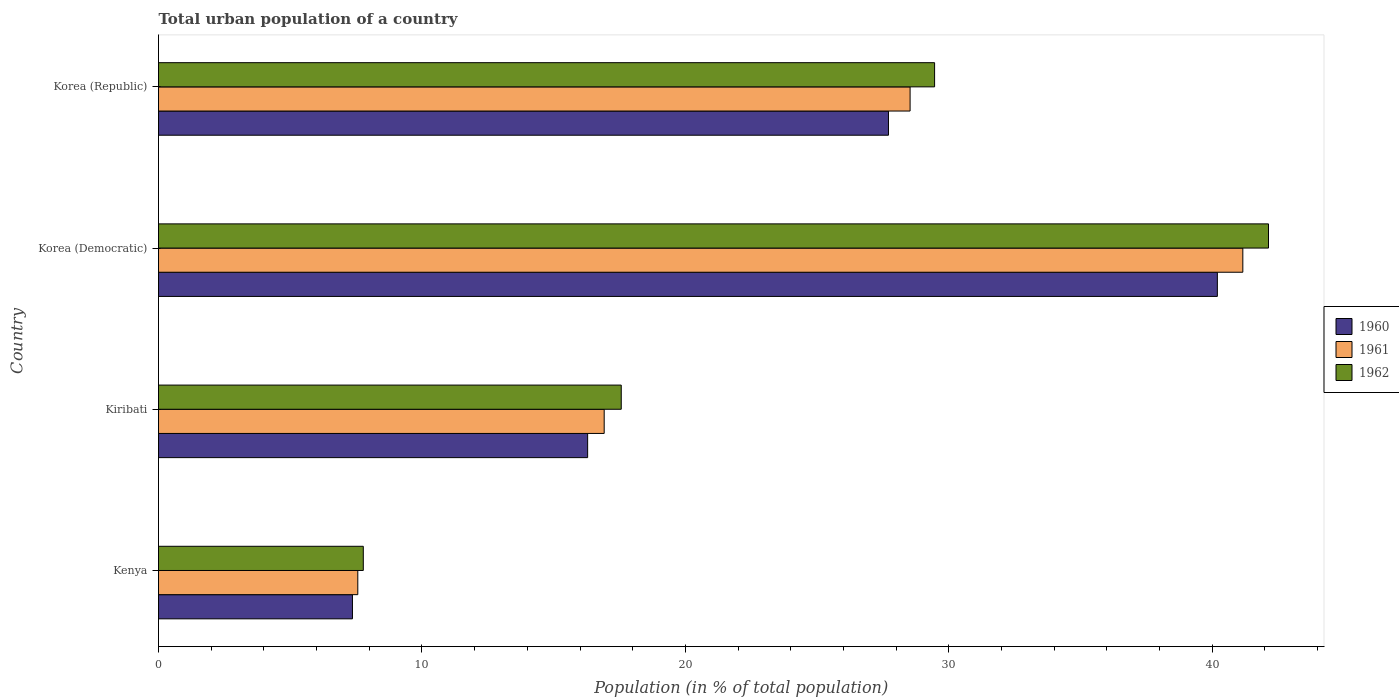How many groups of bars are there?
Your answer should be compact. 4. Are the number of bars per tick equal to the number of legend labels?
Ensure brevity in your answer.  Yes. How many bars are there on the 2nd tick from the top?
Your response must be concise. 3. How many bars are there on the 3rd tick from the bottom?
Ensure brevity in your answer.  3. What is the urban population in 1962 in Korea (Republic)?
Your answer should be compact. 29.46. Across all countries, what is the maximum urban population in 1960?
Give a very brief answer. 40.2. Across all countries, what is the minimum urban population in 1960?
Offer a terse response. 7.36. In which country was the urban population in 1960 maximum?
Your answer should be very brief. Korea (Democratic). In which country was the urban population in 1962 minimum?
Provide a short and direct response. Kenya. What is the total urban population in 1960 in the graph?
Your answer should be very brief. 91.56. What is the difference between the urban population in 1960 in Kenya and that in Korea (Republic)?
Make the answer very short. -20.35. What is the difference between the urban population in 1960 in Kiribati and the urban population in 1961 in Kenya?
Provide a short and direct response. 8.72. What is the average urban population in 1961 per country?
Offer a terse response. 23.54. What is the difference between the urban population in 1962 and urban population in 1960 in Korea (Democratic)?
Your answer should be compact. 1.94. What is the ratio of the urban population in 1960 in Kenya to that in Korea (Republic)?
Keep it short and to the point. 0.27. Is the urban population in 1962 in Kiribati less than that in Korea (Republic)?
Keep it short and to the point. Yes. Is the difference between the urban population in 1962 in Kiribati and Korea (Democratic) greater than the difference between the urban population in 1960 in Kiribati and Korea (Democratic)?
Offer a terse response. No. What is the difference between the highest and the second highest urban population in 1962?
Give a very brief answer. 12.68. What is the difference between the highest and the lowest urban population in 1962?
Provide a succinct answer. 34.36. In how many countries, is the urban population in 1961 greater than the average urban population in 1961 taken over all countries?
Your answer should be compact. 2. Is the sum of the urban population in 1960 in Kiribati and Korea (Democratic) greater than the maximum urban population in 1961 across all countries?
Offer a very short reply. Yes. What does the 2nd bar from the bottom in Korea (Republic) represents?
Your response must be concise. 1961. Is it the case that in every country, the sum of the urban population in 1962 and urban population in 1961 is greater than the urban population in 1960?
Provide a short and direct response. Yes. Are all the bars in the graph horizontal?
Your answer should be very brief. Yes. What is the difference between two consecutive major ticks on the X-axis?
Ensure brevity in your answer.  10. Are the values on the major ticks of X-axis written in scientific E-notation?
Make the answer very short. No. Does the graph contain any zero values?
Give a very brief answer. No. Where does the legend appear in the graph?
Your response must be concise. Center right. What is the title of the graph?
Provide a short and direct response. Total urban population of a country. What is the label or title of the X-axis?
Offer a very short reply. Population (in % of total population). What is the label or title of the Y-axis?
Offer a very short reply. Country. What is the Population (in % of total population) in 1960 in Kenya?
Ensure brevity in your answer.  7.36. What is the Population (in % of total population) in 1961 in Kenya?
Your answer should be compact. 7.57. What is the Population (in % of total population) of 1962 in Kenya?
Keep it short and to the point. 7.77. What is the Population (in % of total population) in 1960 in Kiribati?
Make the answer very short. 16.29. What is the Population (in % of total population) of 1961 in Kiribati?
Give a very brief answer. 16.92. What is the Population (in % of total population) of 1962 in Kiribati?
Provide a succinct answer. 17.57. What is the Population (in % of total population) in 1960 in Korea (Democratic)?
Your answer should be very brief. 40.2. What is the Population (in % of total population) in 1961 in Korea (Democratic)?
Provide a short and direct response. 41.16. What is the Population (in % of total population) in 1962 in Korea (Democratic)?
Your answer should be very brief. 42.14. What is the Population (in % of total population) in 1960 in Korea (Republic)?
Your answer should be very brief. 27.71. What is the Population (in % of total population) in 1961 in Korea (Republic)?
Provide a succinct answer. 28.53. What is the Population (in % of total population) in 1962 in Korea (Republic)?
Provide a short and direct response. 29.46. Across all countries, what is the maximum Population (in % of total population) of 1960?
Offer a very short reply. 40.2. Across all countries, what is the maximum Population (in % of total population) of 1961?
Offer a very short reply. 41.16. Across all countries, what is the maximum Population (in % of total population) in 1962?
Offer a very short reply. 42.14. Across all countries, what is the minimum Population (in % of total population) in 1960?
Your answer should be very brief. 7.36. Across all countries, what is the minimum Population (in % of total population) of 1961?
Provide a succinct answer. 7.57. Across all countries, what is the minimum Population (in % of total population) of 1962?
Keep it short and to the point. 7.77. What is the total Population (in % of total population) of 1960 in the graph?
Make the answer very short. 91.56. What is the total Population (in % of total population) in 1961 in the graph?
Your answer should be very brief. 94.18. What is the total Population (in % of total population) in 1962 in the graph?
Your response must be concise. 96.94. What is the difference between the Population (in % of total population) in 1960 in Kenya and that in Kiribati?
Provide a short and direct response. -8.93. What is the difference between the Population (in % of total population) of 1961 in Kenya and that in Kiribati?
Offer a terse response. -9.35. What is the difference between the Population (in % of total population) of 1962 in Kenya and that in Kiribati?
Provide a short and direct response. -9.79. What is the difference between the Population (in % of total population) in 1960 in Kenya and that in Korea (Democratic)?
Make the answer very short. -32.83. What is the difference between the Population (in % of total population) in 1961 in Kenya and that in Korea (Democratic)?
Offer a very short reply. -33.6. What is the difference between the Population (in % of total population) of 1962 in Kenya and that in Korea (Democratic)?
Provide a short and direct response. -34.36. What is the difference between the Population (in % of total population) in 1960 in Kenya and that in Korea (Republic)?
Your response must be concise. -20.35. What is the difference between the Population (in % of total population) of 1961 in Kenya and that in Korea (Republic)?
Your answer should be compact. -20.97. What is the difference between the Population (in % of total population) of 1962 in Kenya and that in Korea (Republic)?
Ensure brevity in your answer.  -21.69. What is the difference between the Population (in % of total population) of 1960 in Kiribati and that in Korea (Democratic)?
Offer a terse response. -23.91. What is the difference between the Population (in % of total population) of 1961 in Kiribati and that in Korea (Democratic)?
Provide a succinct answer. -24.24. What is the difference between the Population (in % of total population) of 1962 in Kiribati and that in Korea (Democratic)?
Offer a terse response. -24.57. What is the difference between the Population (in % of total population) in 1960 in Kiribati and that in Korea (Republic)?
Offer a very short reply. -11.42. What is the difference between the Population (in % of total population) in 1961 in Kiribati and that in Korea (Republic)?
Offer a terse response. -11.61. What is the difference between the Population (in % of total population) in 1962 in Kiribati and that in Korea (Republic)?
Keep it short and to the point. -11.89. What is the difference between the Population (in % of total population) in 1960 in Korea (Democratic) and that in Korea (Republic)?
Provide a succinct answer. 12.48. What is the difference between the Population (in % of total population) in 1961 in Korea (Democratic) and that in Korea (Republic)?
Your response must be concise. 12.63. What is the difference between the Population (in % of total population) in 1962 in Korea (Democratic) and that in Korea (Republic)?
Your response must be concise. 12.68. What is the difference between the Population (in % of total population) of 1960 in Kenya and the Population (in % of total population) of 1961 in Kiribati?
Provide a short and direct response. -9.56. What is the difference between the Population (in % of total population) of 1960 in Kenya and the Population (in % of total population) of 1962 in Kiribati?
Your answer should be compact. -10.2. What is the difference between the Population (in % of total population) of 1961 in Kenya and the Population (in % of total population) of 1962 in Kiribati?
Your answer should be compact. -10. What is the difference between the Population (in % of total population) in 1960 in Kenya and the Population (in % of total population) in 1961 in Korea (Democratic)?
Your answer should be compact. -33.8. What is the difference between the Population (in % of total population) in 1960 in Kenya and the Population (in % of total population) in 1962 in Korea (Democratic)?
Keep it short and to the point. -34.77. What is the difference between the Population (in % of total population) in 1961 in Kenya and the Population (in % of total population) in 1962 in Korea (Democratic)?
Provide a short and direct response. -34.57. What is the difference between the Population (in % of total population) of 1960 in Kenya and the Population (in % of total population) of 1961 in Korea (Republic)?
Give a very brief answer. -21.17. What is the difference between the Population (in % of total population) in 1960 in Kenya and the Population (in % of total population) in 1962 in Korea (Republic)?
Ensure brevity in your answer.  -22.1. What is the difference between the Population (in % of total population) of 1961 in Kenya and the Population (in % of total population) of 1962 in Korea (Republic)?
Give a very brief answer. -21.9. What is the difference between the Population (in % of total population) in 1960 in Kiribati and the Population (in % of total population) in 1961 in Korea (Democratic)?
Give a very brief answer. -24.87. What is the difference between the Population (in % of total population) of 1960 in Kiribati and the Population (in % of total population) of 1962 in Korea (Democratic)?
Your response must be concise. -25.85. What is the difference between the Population (in % of total population) of 1961 in Kiribati and the Population (in % of total population) of 1962 in Korea (Democratic)?
Offer a terse response. -25.22. What is the difference between the Population (in % of total population) of 1960 in Kiribati and the Population (in % of total population) of 1961 in Korea (Republic)?
Offer a very short reply. -12.24. What is the difference between the Population (in % of total population) in 1960 in Kiribati and the Population (in % of total population) in 1962 in Korea (Republic)?
Provide a succinct answer. -13.17. What is the difference between the Population (in % of total population) of 1961 in Kiribati and the Population (in % of total population) of 1962 in Korea (Republic)?
Provide a short and direct response. -12.54. What is the difference between the Population (in % of total population) of 1960 in Korea (Democratic) and the Population (in % of total population) of 1961 in Korea (Republic)?
Give a very brief answer. 11.66. What is the difference between the Population (in % of total population) of 1960 in Korea (Democratic) and the Population (in % of total population) of 1962 in Korea (Republic)?
Make the answer very short. 10.73. What is the difference between the Population (in % of total population) of 1961 in Korea (Democratic) and the Population (in % of total population) of 1962 in Korea (Republic)?
Offer a terse response. 11.7. What is the average Population (in % of total population) of 1960 per country?
Make the answer very short. 22.89. What is the average Population (in % of total population) in 1961 per country?
Keep it short and to the point. 23.54. What is the average Population (in % of total population) in 1962 per country?
Your answer should be compact. 24.23. What is the difference between the Population (in % of total population) in 1960 and Population (in % of total population) in 1961 in Kenya?
Ensure brevity in your answer.  -0.2. What is the difference between the Population (in % of total population) of 1960 and Population (in % of total population) of 1962 in Kenya?
Keep it short and to the point. -0.41. What is the difference between the Population (in % of total population) in 1961 and Population (in % of total population) in 1962 in Kenya?
Your response must be concise. -0.21. What is the difference between the Population (in % of total population) of 1960 and Population (in % of total population) of 1961 in Kiribati?
Ensure brevity in your answer.  -0.63. What is the difference between the Population (in % of total population) of 1960 and Population (in % of total population) of 1962 in Kiribati?
Offer a terse response. -1.28. What is the difference between the Population (in % of total population) in 1961 and Population (in % of total population) in 1962 in Kiribati?
Provide a short and direct response. -0.65. What is the difference between the Population (in % of total population) of 1960 and Population (in % of total population) of 1961 in Korea (Democratic)?
Give a very brief answer. -0.97. What is the difference between the Population (in % of total population) of 1960 and Population (in % of total population) of 1962 in Korea (Democratic)?
Your answer should be compact. -1.94. What is the difference between the Population (in % of total population) in 1961 and Population (in % of total population) in 1962 in Korea (Democratic)?
Keep it short and to the point. -0.97. What is the difference between the Population (in % of total population) in 1960 and Population (in % of total population) in 1961 in Korea (Republic)?
Ensure brevity in your answer.  -0.82. What is the difference between the Population (in % of total population) in 1960 and Population (in % of total population) in 1962 in Korea (Republic)?
Keep it short and to the point. -1.75. What is the difference between the Population (in % of total population) of 1961 and Population (in % of total population) of 1962 in Korea (Republic)?
Your answer should be compact. -0.93. What is the ratio of the Population (in % of total population) in 1960 in Kenya to that in Kiribati?
Provide a short and direct response. 0.45. What is the ratio of the Population (in % of total population) in 1961 in Kenya to that in Kiribati?
Keep it short and to the point. 0.45. What is the ratio of the Population (in % of total population) of 1962 in Kenya to that in Kiribati?
Keep it short and to the point. 0.44. What is the ratio of the Population (in % of total population) of 1960 in Kenya to that in Korea (Democratic)?
Your answer should be compact. 0.18. What is the ratio of the Population (in % of total population) of 1961 in Kenya to that in Korea (Democratic)?
Make the answer very short. 0.18. What is the ratio of the Population (in % of total population) of 1962 in Kenya to that in Korea (Democratic)?
Offer a very short reply. 0.18. What is the ratio of the Population (in % of total population) in 1960 in Kenya to that in Korea (Republic)?
Provide a succinct answer. 0.27. What is the ratio of the Population (in % of total population) in 1961 in Kenya to that in Korea (Republic)?
Provide a short and direct response. 0.27. What is the ratio of the Population (in % of total population) in 1962 in Kenya to that in Korea (Republic)?
Your answer should be very brief. 0.26. What is the ratio of the Population (in % of total population) in 1960 in Kiribati to that in Korea (Democratic)?
Your answer should be very brief. 0.41. What is the ratio of the Population (in % of total population) of 1961 in Kiribati to that in Korea (Democratic)?
Offer a very short reply. 0.41. What is the ratio of the Population (in % of total population) of 1962 in Kiribati to that in Korea (Democratic)?
Provide a succinct answer. 0.42. What is the ratio of the Population (in % of total population) in 1960 in Kiribati to that in Korea (Republic)?
Give a very brief answer. 0.59. What is the ratio of the Population (in % of total population) of 1961 in Kiribati to that in Korea (Republic)?
Make the answer very short. 0.59. What is the ratio of the Population (in % of total population) of 1962 in Kiribati to that in Korea (Republic)?
Offer a very short reply. 0.6. What is the ratio of the Population (in % of total population) of 1960 in Korea (Democratic) to that in Korea (Republic)?
Keep it short and to the point. 1.45. What is the ratio of the Population (in % of total population) of 1961 in Korea (Democratic) to that in Korea (Republic)?
Give a very brief answer. 1.44. What is the ratio of the Population (in % of total population) in 1962 in Korea (Democratic) to that in Korea (Republic)?
Your answer should be very brief. 1.43. What is the difference between the highest and the second highest Population (in % of total population) in 1960?
Offer a very short reply. 12.48. What is the difference between the highest and the second highest Population (in % of total population) in 1961?
Provide a succinct answer. 12.63. What is the difference between the highest and the second highest Population (in % of total population) of 1962?
Ensure brevity in your answer.  12.68. What is the difference between the highest and the lowest Population (in % of total population) in 1960?
Ensure brevity in your answer.  32.83. What is the difference between the highest and the lowest Population (in % of total population) of 1961?
Your response must be concise. 33.6. What is the difference between the highest and the lowest Population (in % of total population) in 1962?
Offer a terse response. 34.36. 